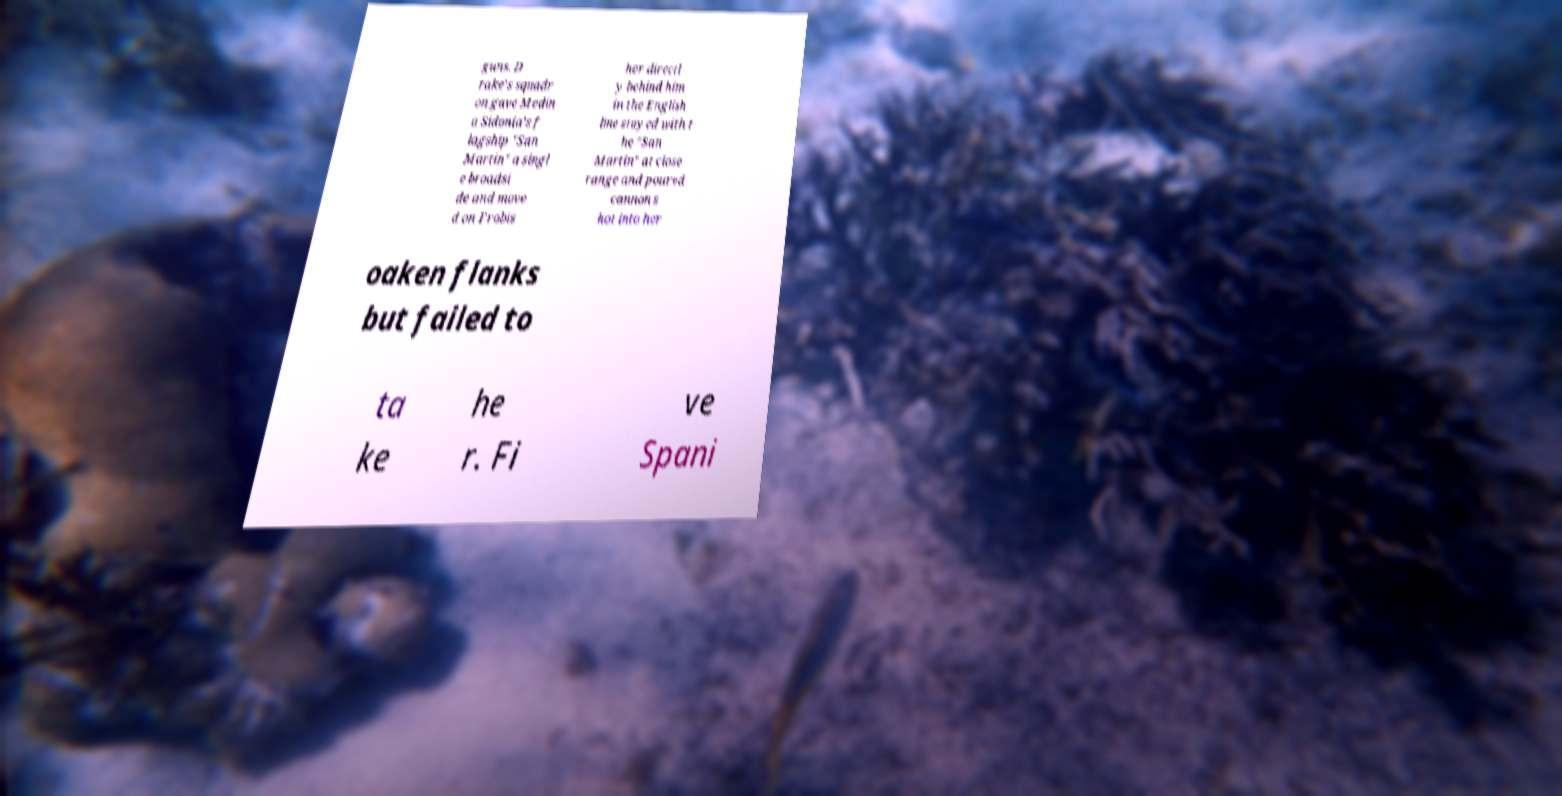For documentation purposes, I need the text within this image transcribed. Could you provide that? guns. D rake's squadr on gave Medin a Sidonia's f lagship "San Martin" a singl e broadsi de and move d on Frobis her directl y behind him in the English line stayed with t he "San Martin" at close range and poured cannon s hot into her oaken flanks but failed to ta ke he r. Fi ve Spani 